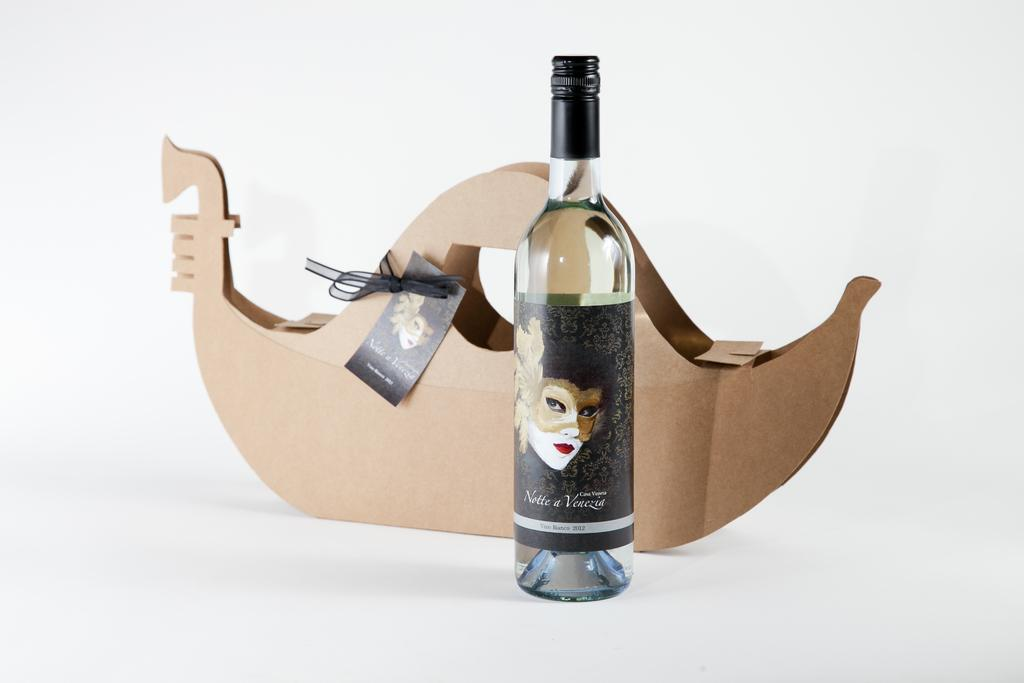<image>
Present a compact description of the photo's key features. A bottle of 2012 wine with a black label and the profile of a woman behind the bottle a brown box shaped as a boat. 